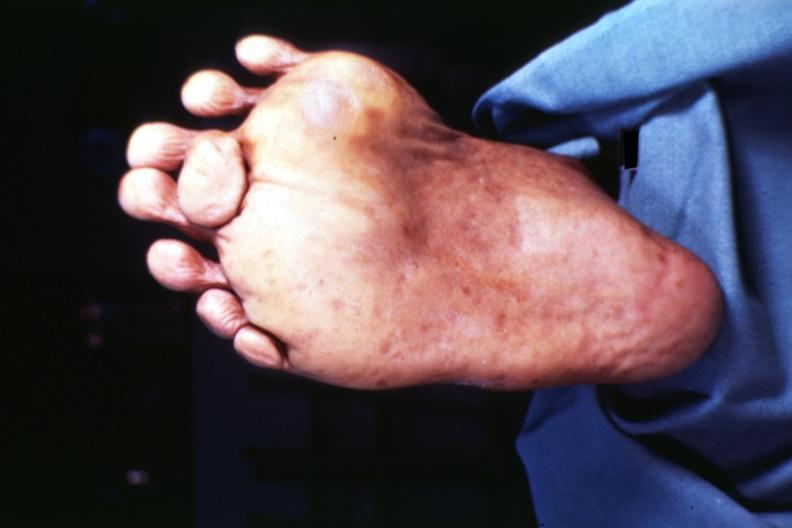s supernumerary digits present?
Answer the question using a single word or phrase. Yes 